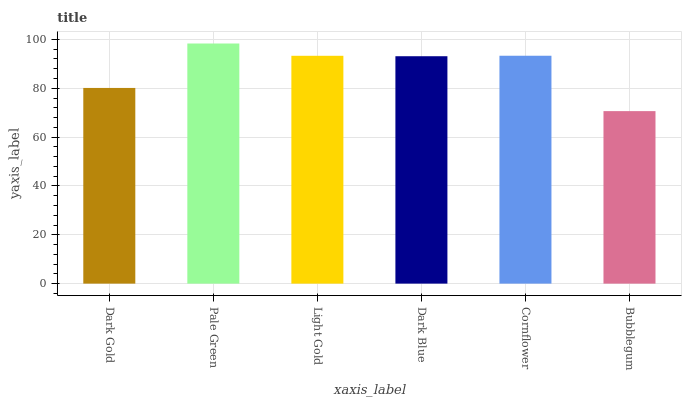Is Light Gold the minimum?
Answer yes or no. No. Is Light Gold the maximum?
Answer yes or no. No. Is Pale Green greater than Light Gold?
Answer yes or no. Yes. Is Light Gold less than Pale Green?
Answer yes or no. Yes. Is Light Gold greater than Pale Green?
Answer yes or no. No. Is Pale Green less than Light Gold?
Answer yes or no. No. Is Light Gold the high median?
Answer yes or no. Yes. Is Dark Blue the low median?
Answer yes or no. Yes. Is Dark Gold the high median?
Answer yes or no. No. Is Cornflower the low median?
Answer yes or no. No. 